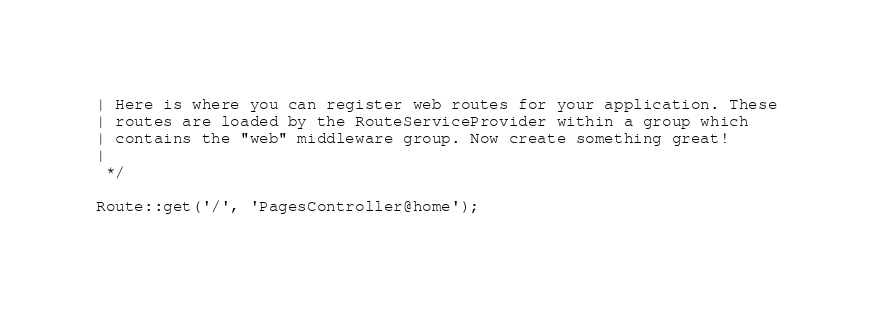<code> <loc_0><loc_0><loc_500><loc_500><_PHP_>| Here is where you can register web routes for your application. These
| routes are loaded by the RouteServiceProvider within a group which
| contains the "web" middleware group. Now create something great!
|
 */

Route::get('/', 'PagesController@home');
</code> 